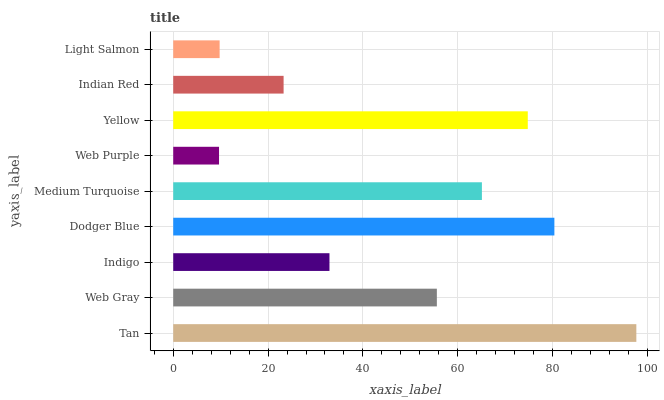Is Web Purple the minimum?
Answer yes or no. Yes. Is Tan the maximum?
Answer yes or no. Yes. Is Web Gray the minimum?
Answer yes or no. No. Is Web Gray the maximum?
Answer yes or no. No. Is Tan greater than Web Gray?
Answer yes or no. Yes. Is Web Gray less than Tan?
Answer yes or no. Yes. Is Web Gray greater than Tan?
Answer yes or no. No. Is Tan less than Web Gray?
Answer yes or no. No. Is Web Gray the high median?
Answer yes or no. Yes. Is Web Gray the low median?
Answer yes or no. Yes. Is Indigo the high median?
Answer yes or no. No. Is Light Salmon the low median?
Answer yes or no. No. 